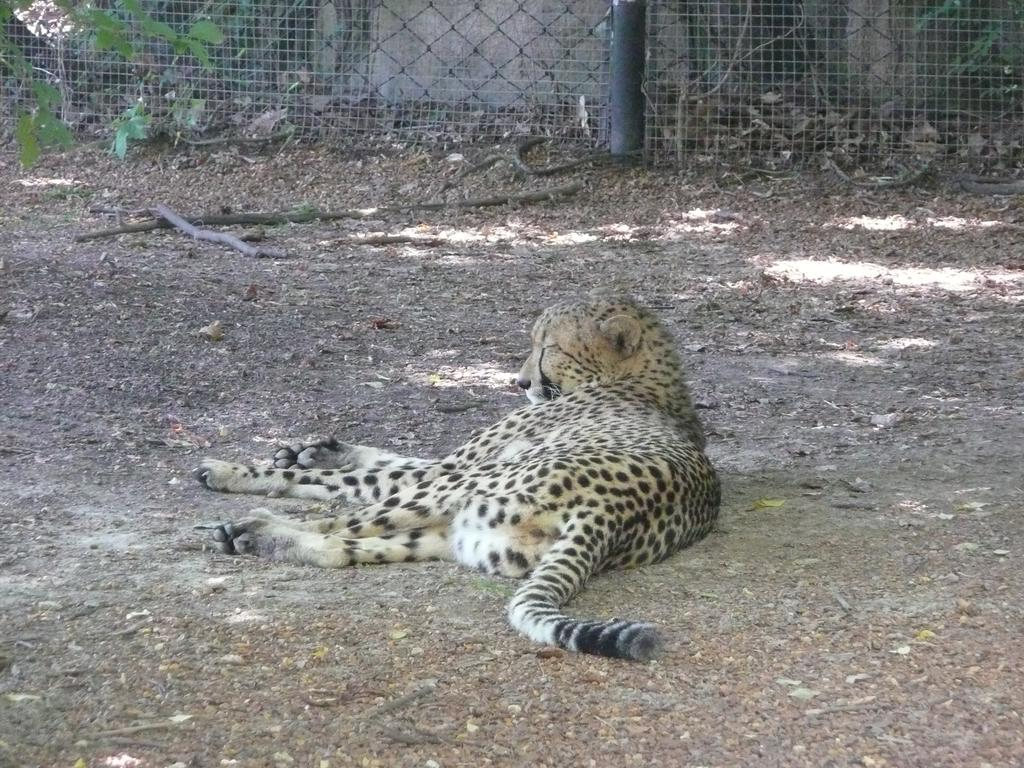What animal is the main subject of the image? There is a cheetah in the image. What is the cheetah doing in the image? The cheetah is sleeping in the image. Where is the cheetah located in the image? The cheetah is on the ground in the image. What can be seen in the background of the image? There is fencing in the background of the image. What type of vegetation is present near the fencing? Small plants are present near the fencing in the image. What type of minute can be seen solving a riddle in the image? There is no minute or riddle present in the image; it features a cheetah sleeping on the ground. What game is the cheetah playing with the small plants in the image? There is no game being played in the image; the cheetah is sleeping, and the small plants are simply present near the fencing. 